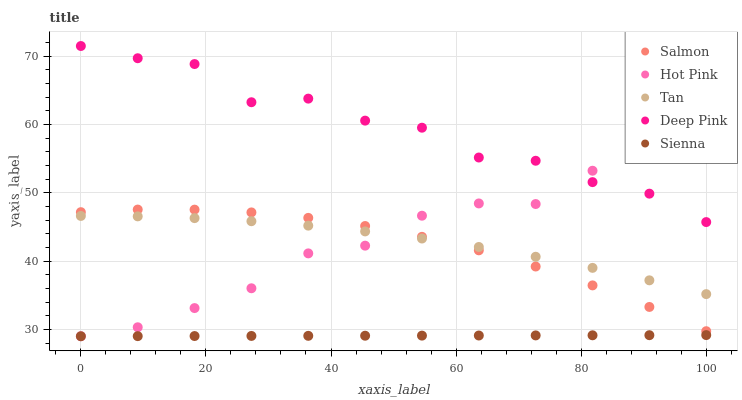Does Sienna have the minimum area under the curve?
Answer yes or no. Yes. Does Deep Pink have the maximum area under the curve?
Answer yes or no. Yes. Does Tan have the minimum area under the curve?
Answer yes or no. No. Does Tan have the maximum area under the curve?
Answer yes or no. No. Is Sienna the smoothest?
Answer yes or no. Yes. Is Deep Pink the roughest?
Answer yes or no. Yes. Is Tan the smoothest?
Answer yes or no. No. Is Tan the roughest?
Answer yes or no. No. Does Sienna have the lowest value?
Answer yes or no. Yes. Does Tan have the lowest value?
Answer yes or no. No. Does Deep Pink have the highest value?
Answer yes or no. Yes. Does Tan have the highest value?
Answer yes or no. No. Is Tan less than Deep Pink?
Answer yes or no. Yes. Is Deep Pink greater than Salmon?
Answer yes or no. Yes. Does Hot Pink intersect Sienna?
Answer yes or no. Yes. Is Hot Pink less than Sienna?
Answer yes or no. No. Is Hot Pink greater than Sienna?
Answer yes or no. No. Does Tan intersect Deep Pink?
Answer yes or no. No. 